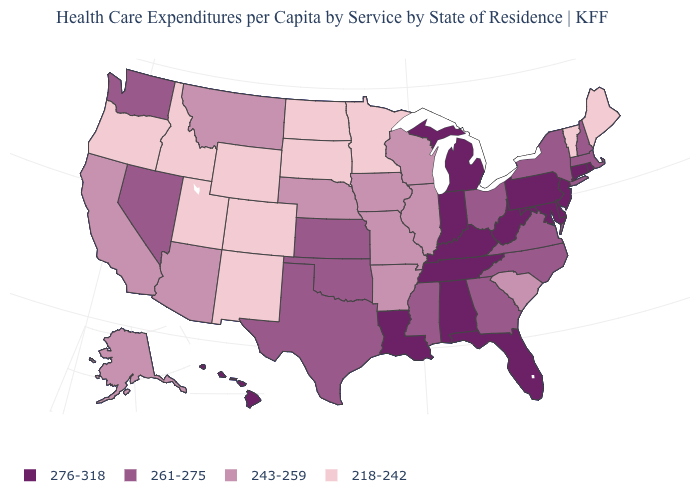Among the states that border Mississippi , does Arkansas have the highest value?
Give a very brief answer. No. Name the states that have a value in the range 243-259?
Answer briefly. Alaska, Arizona, Arkansas, California, Illinois, Iowa, Missouri, Montana, Nebraska, South Carolina, Wisconsin. What is the lowest value in the USA?
Short answer required. 218-242. What is the value of New Hampshire?
Give a very brief answer. 261-275. Name the states that have a value in the range 261-275?
Give a very brief answer. Georgia, Kansas, Massachusetts, Mississippi, Nevada, New Hampshire, New York, North Carolina, Ohio, Oklahoma, Texas, Virginia, Washington. Which states have the lowest value in the USA?
Short answer required. Colorado, Idaho, Maine, Minnesota, New Mexico, North Dakota, Oregon, South Dakota, Utah, Vermont, Wyoming. Among the states that border Illinois , which have the highest value?
Give a very brief answer. Indiana, Kentucky. What is the value of North Dakota?
Answer briefly. 218-242. Name the states that have a value in the range 276-318?
Concise answer only. Alabama, Connecticut, Delaware, Florida, Hawaii, Indiana, Kentucky, Louisiana, Maryland, Michigan, New Jersey, Pennsylvania, Rhode Island, Tennessee, West Virginia. Name the states that have a value in the range 276-318?
Give a very brief answer. Alabama, Connecticut, Delaware, Florida, Hawaii, Indiana, Kentucky, Louisiana, Maryland, Michigan, New Jersey, Pennsylvania, Rhode Island, Tennessee, West Virginia. Is the legend a continuous bar?
Keep it brief. No. Among the states that border North Carolina , does South Carolina have the highest value?
Concise answer only. No. What is the value of Wyoming?
Write a very short answer. 218-242. Name the states that have a value in the range 243-259?
Write a very short answer. Alaska, Arizona, Arkansas, California, Illinois, Iowa, Missouri, Montana, Nebraska, South Carolina, Wisconsin. Does Colorado have the lowest value in the USA?
Write a very short answer. Yes. 